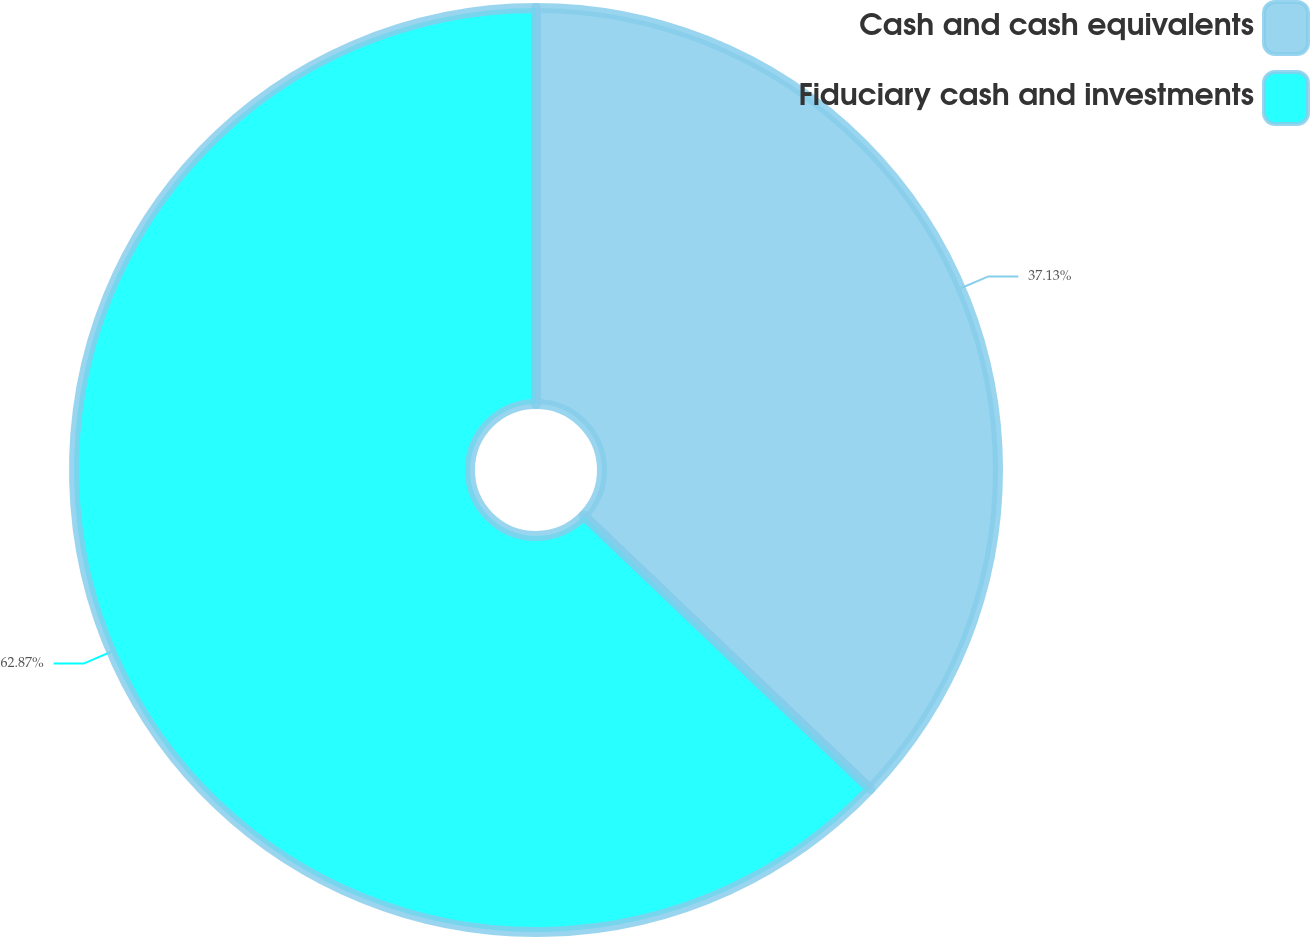<chart> <loc_0><loc_0><loc_500><loc_500><pie_chart><fcel>Cash and cash equivalents<fcel>Fiduciary cash and investments<nl><fcel>37.13%<fcel>62.87%<nl></chart> 